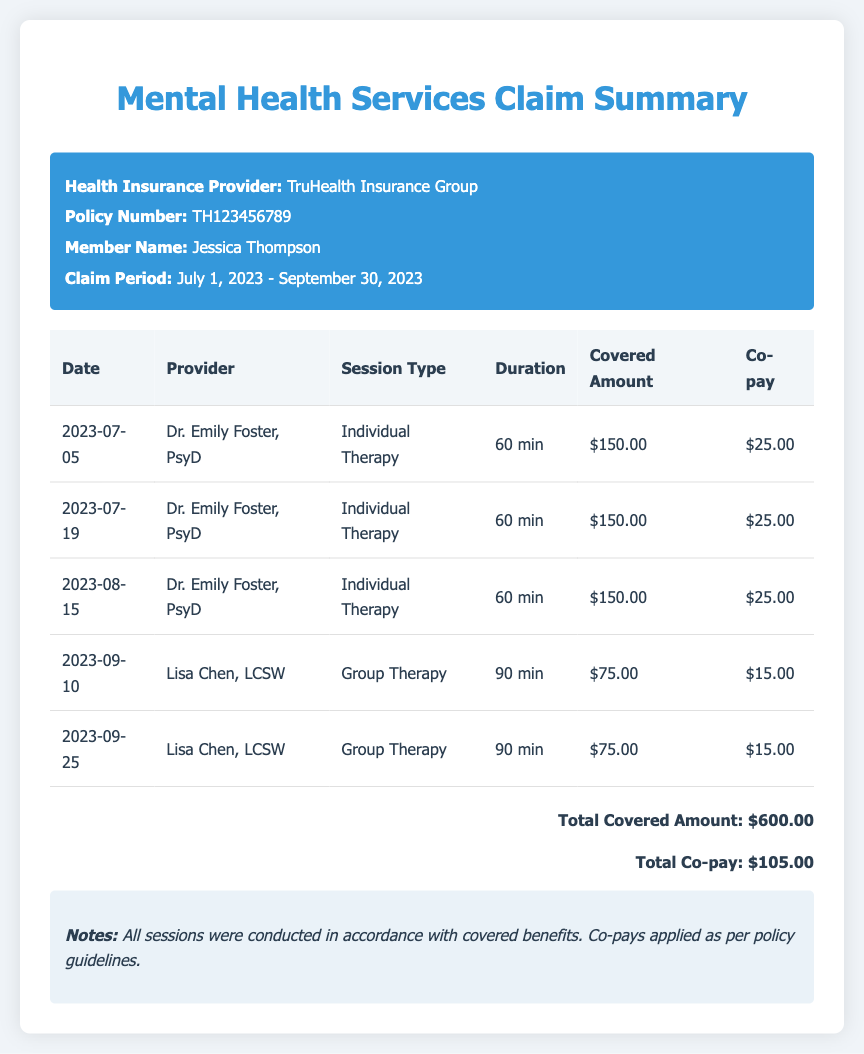what is the health insurance provider? The health insurance provider is mentioned at the top of the document within the header section.
Answer: TruHealth Insurance Group who is the member named in the document? The member's name is indicated in the header section of the document.
Answer: Jessica Thompson what is the total covered amount? The total covered amount is stated at the bottom of the document summarizing the claims for the period.
Answer: $600.00 how many individual therapy sessions were conducted? The document lists the types of sessions and their respective counts in the table.
Answer: 3 what is the co-pay amount for the last session? The co-pay for each session is listed in the table under the corresponding session.
Answer: $15.00 what is the duration of the group therapy sessions? The duration for each session type is listed in the table.
Answer: 90 min which providers delivered the services listed? The providers' names are noted in the second column of the service details table.
Answer: Dr. Emily Foster, PsyD and Lisa Chen, LCSW what is the claim period covered in the document? The claim period is highlighted in the header section of the document.
Answer: July 1, 2023 - September 30, 2023 what is the total co-pay amount for all sessions? The total co-pay is summarized at the bottom of the document.
Answer: $105.00 